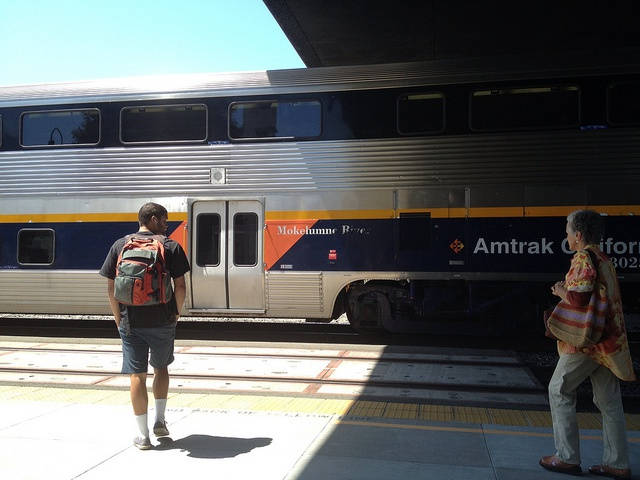Describe the objects in this image and their specific colors. I can see train in lightblue, black, darkgray, gray, and lightgray tones, people in lightblue, black, gray, darkblue, and maroon tones, people in lightblue, black, gray, maroon, and darkgray tones, backpack in lightblue, black, maroon, gray, and darkgray tones, and handbag in lightblue, black, gray, and maroon tones in this image. 